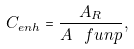<formula> <loc_0><loc_0><loc_500><loc_500>C _ { e n h } = \frac { A _ { R } } { A _ { \ } f u n p } ,</formula> 